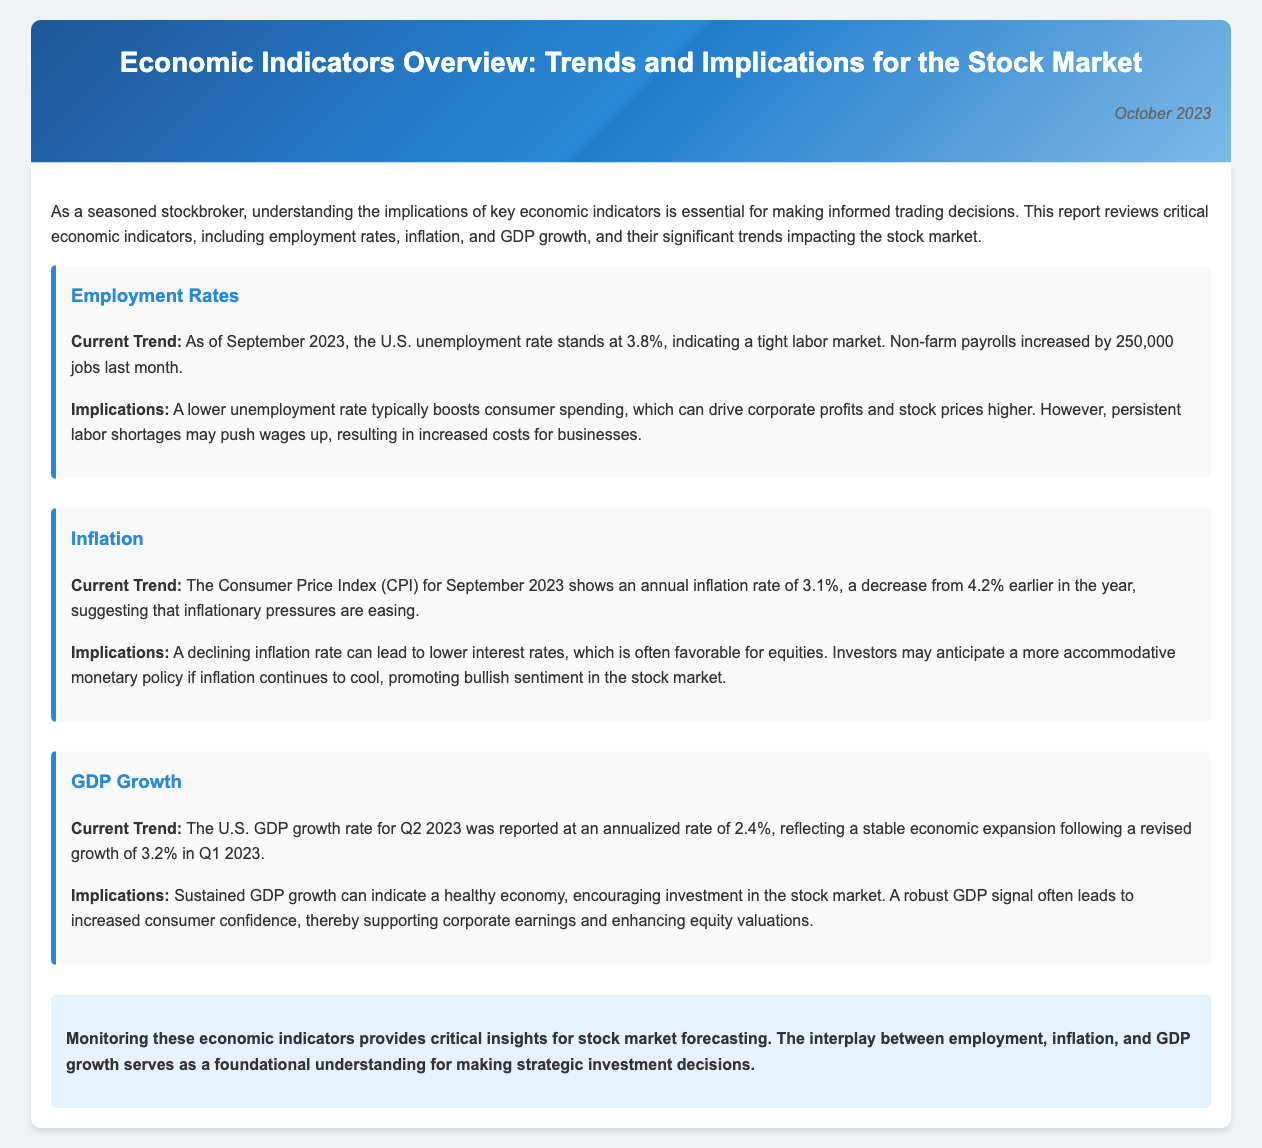What is the unemployment rate as of September 2023? The unemployment rate is a critical economic indicator that helps gauge the labor market status. According to the document, it stands at 3.8%.
Answer: 3.8% How many jobs were added last month? The document states that non-farm payrolls increased by 250,000 jobs last month, which contributes to the understanding of employment trends.
Answer: 250,000 What was the annual inflation rate in September 2023? The annual inflation rate is an important measure of price changes in the economy. The document mentions it as 3.1%.
Answer: 3.1% What was the U.S. GDP growth rate for Q2 2023? The GDP growth rate is crucial for assessing economic performance. The document reports it at an annualized rate of 2.4% for Q2 2023.
Answer: 2.4% What effect does a lower unemployment rate have on consumer spending? The relationship between unemployment rates and consumer behavior is vital for market predictions. The document indicates that a lower unemployment rate typically boosts consumer spending.
Answer: Boosts consumer spending What might happen if inflation continues to decrease? Understanding the potential outcomes of declining inflation helps in anticipating market reactions. The document suggests that it may lead to lower interest rates and a more accommodative monetary policy.
Answer: Lower interest rates How did the GDP growth rate change from Q1 2023 to Q2 2023? This question addresses economic growth trends over the quarters. The document reveals that GDP growth decreased from 3.2% in Q1 to 2.4% in Q2.
Answer: Decreased Which economic indicator serves as a foundational understanding for investment decisions? Identifying key indicators assists in stock market forecasting. The document states that employment, inflation, and GDP growth are foundational indicators.
Answer: Employment, inflation, and GDP growth What is the overall implication of monitoring economic indicators? This question pertains to the document's conclusion about the significance of economic indicators. It emphasizes that they provide critical insights for stock market forecasting.
Answer: Critical insights for stock market forecasting 